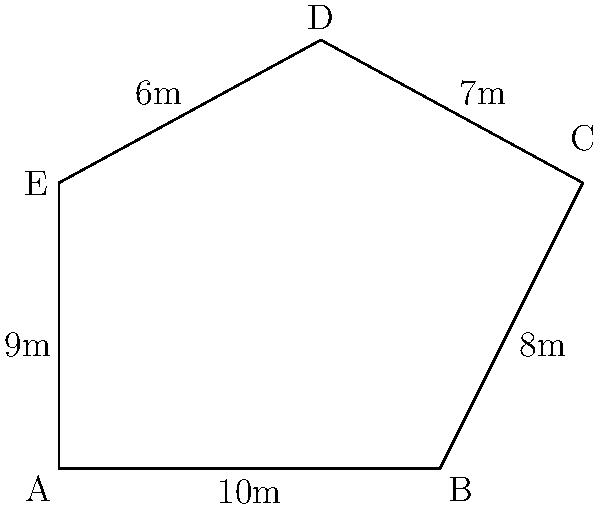You're visiting Cardiff Castle and learn about its pentagonal keep. Given the diagram of the keep's floor plan with side lengths as shown, calculate the area of the pentagonal keep using trigonometry. Round your answer to the nearest square meter. Let's approach this step-by-step:

1) We can divide the pentagon into three triangles: ABC, ACD, and ADE.

2) For triangle ABC:
   - We know two sides: AB = 10m, BC = 8m
   - We can find angle B using the cosine law:
     $$\cos B = \frac{AB^2 + BC^2 - AC^2}{2(AB)(BC)}$$
   - We don't know AC, but we can find it using the other two triangles

3) For triangle ADE:
   - We know all sides: AD = 6m, DE = 9m, AE = 9m
   - We can find angle A using the cosine law:
     $$\cos A = \frac{AD^2 + AE^2 - DE^2}{2(AD)(AE)} = \frac{6^2 + 9^2 - 9^2}{2(6)(9)} = 0.5$$
   - So, angle A = arccos(0.5) ≈ 60°

4) For triangle ACD:
   - We know two sides: AC = 7m, AD = 6m
   - We know angle A = 60°
   - We can find AC using the cosine law:
     $$AC^2 = CD^2 + AD^2 - 2(CD)(AD)\cos A$$
     $$AC^2 = 7^2 + 6^2 - 2(7)(6)\cos 60° ≈ 61$$
     $$AC ≈ 7.81m$$

5) Now we can find angle B in triangle ABC:
   $$\cos B = \frac{10^2 + 8^2 - 7.81^2}{2(10)(8)} ≈ 0.7425$$
   Angle B ≈ 42.2°

6) We can now calculate the areas of the three triangles:
   - Area of ABC = $\frac{1}{2} * 10 * 8 * \sin 42.2° ≈ 26.8m^2$
   - Area of ACD = $\frac{1}{2} * 7 * 6 * \sin 60° ≈ 18.2m^2$
   - Area of ADE = $\frac{1}{2} * 6 * 9 * \sin 60° ≈ 23.4m^2$

7) The total area is the sum of these three triangles:
   26.8 + 18.2 + 23.4 = 68.4m^2

8) Rounding to the nearest square meter: 68m^2
Answer: 68m^2 